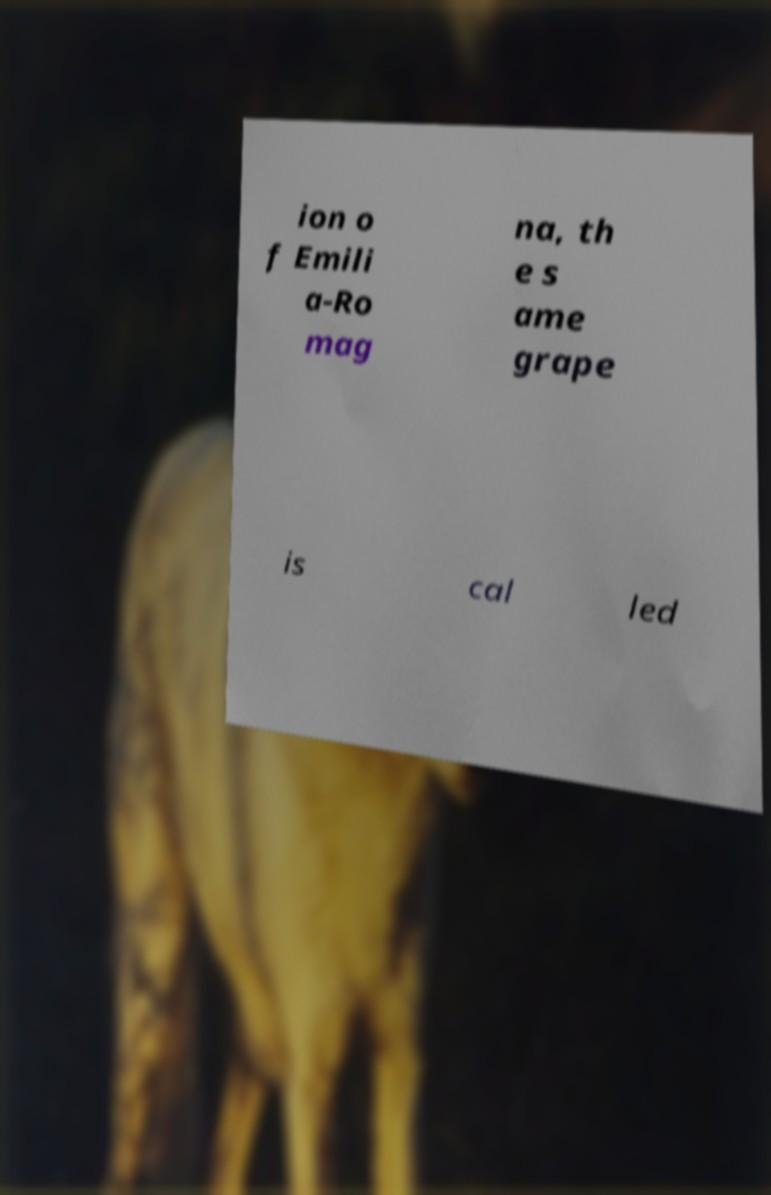Could you extract and type out the text from this image? ion o f Emili a-Ro mag na, th e s ame grape is cal led 